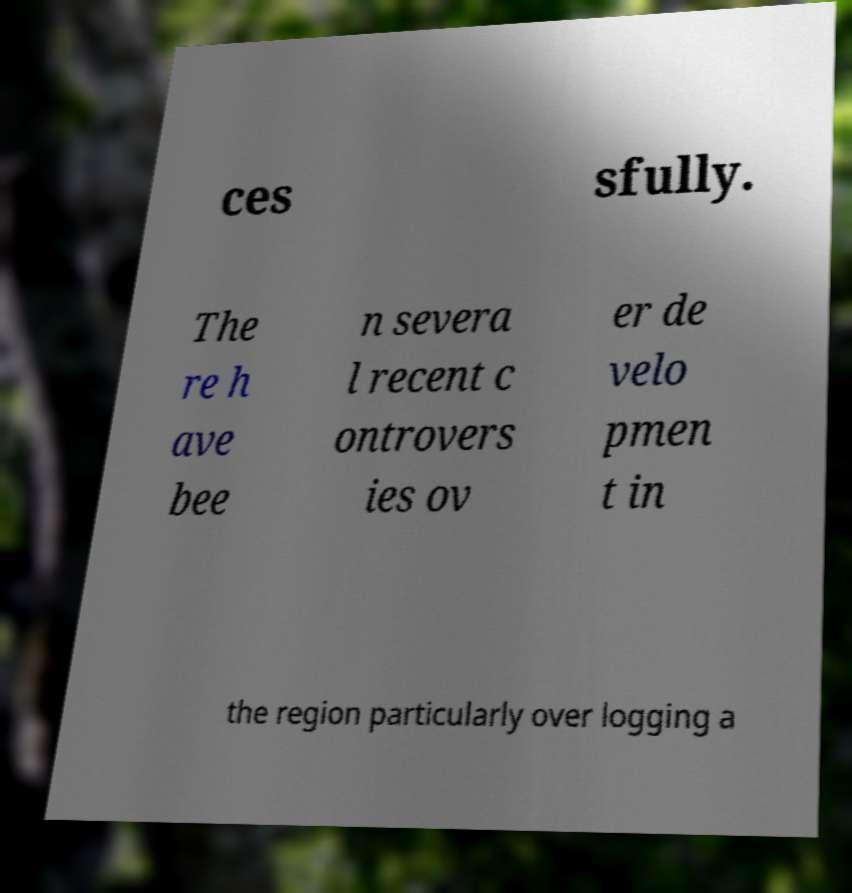There's text embedded in this image that I need extracted. Can you transcribe it verbatim? ces sfully. The re h ave bee n severa l recent c ontrovers ies ov er de velo pmen t in the region particularly over logging a 